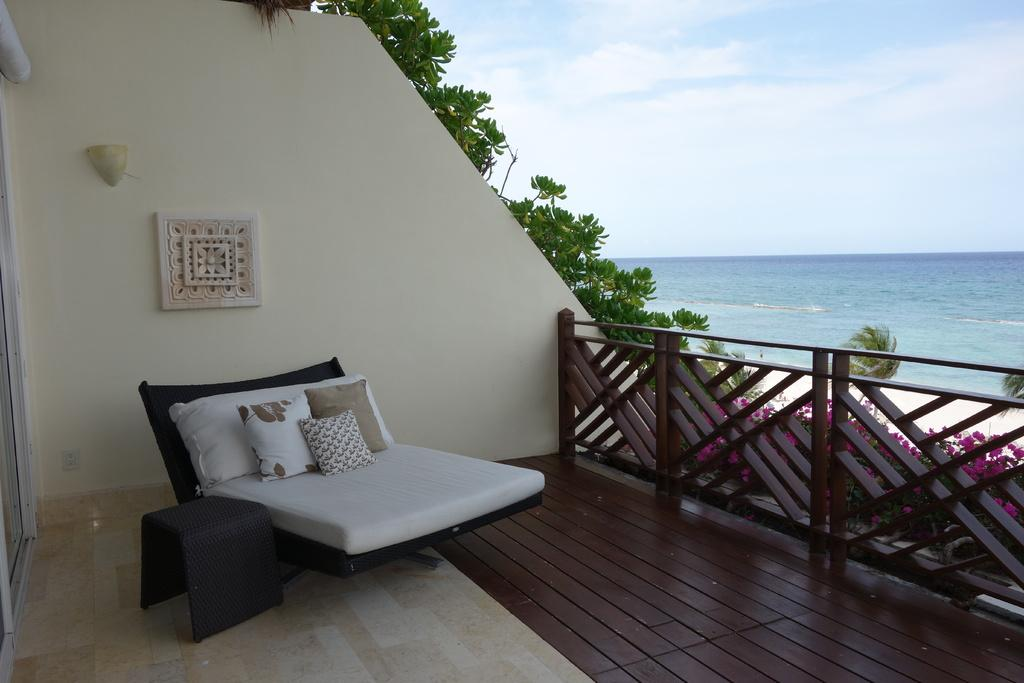What type of furniture is in the image? There is a sofa in the image. What is on the sofa? There are cushions on the sofa. What can be seen in the background of the image? There is an ocean visible in the image. What type of vegetation is on the other side of a wall in the image? There are trees on the other side of a wall in the image. Who is the creator of the pancake in the image? There is no pancake present in the image, so it is not possible to determine who the creator might be. 